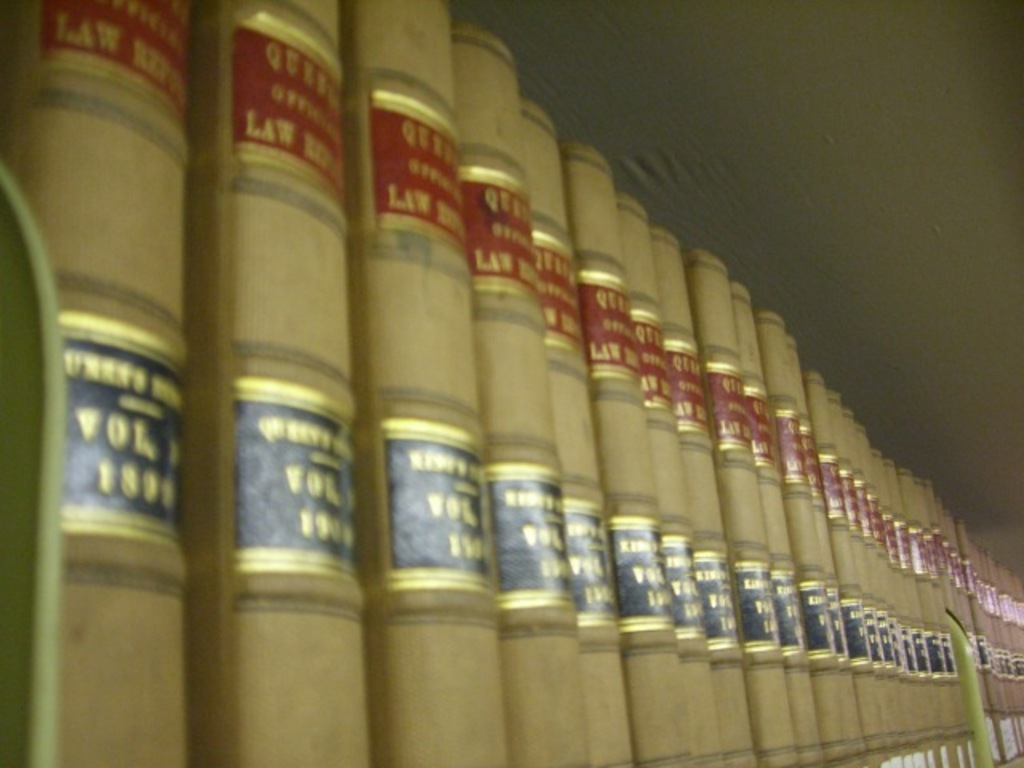Provide a one-sentence caption for the provided image. Rows of red and black law books line a shelf, their gold lettering catching the light, reflecting decades of legal history and knowledge enshrined within their well-thumbed pages. 